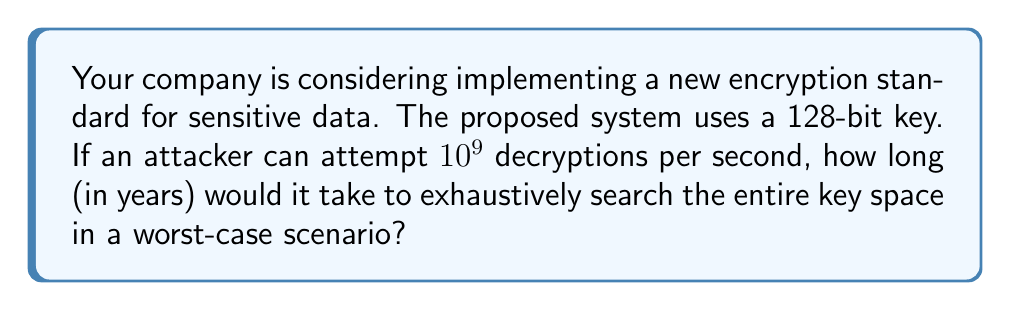Provide a solution to this math problem. Let's approach this step-by-step:

1) First, we need to calculate the total number of possible keys:
   For a 128-bit key, there are $2^{128}$ possible combinations.

2) Now, let's convert the attacker's speed to keys per year:
   Keys per second = $10^9$
   Seconds in a year = $365 \times 24 \times 60 \times 60 = 31,536,000$
   Keys per year = $10^9 \times 31,536,000 = 3.1536 \times 10^{16}$

3) To find the time required, we divide the total number of keys by the number of keys that can be checked per year:

   $$\text{Time (in years)} = \frac{2^{128}}{3.1536 \times 10^{16}}$$

4) Let's calculate this:
   $$\begin{align}
   \text{Time} &= \frac{2^{128}}{3.1536 \times 10^{16}} \\
   &\approx \frac{3.4028 \times 10^{38}}{3.1536 \times 10^{16}} \\
   &\approx 1.0791 \times 10^{22} \text{ years}
   \end{align}$$

5) This is approximately 10.791 sextillion years, which is significantly longer than the current age of the universe (estimated at about 13.8 billion years).
Answer: $1.0791 \times 10^{22}$ years 